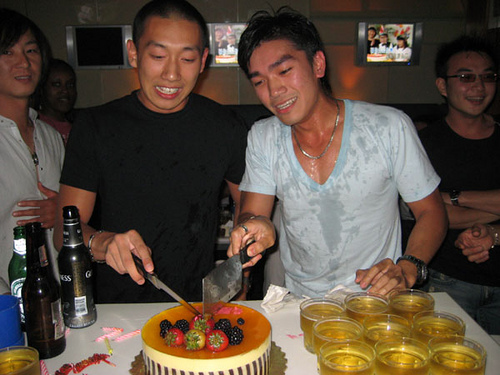What color is the cake? The cake appears to be predominantly orange, likely an orange-flavored or coated cake. 